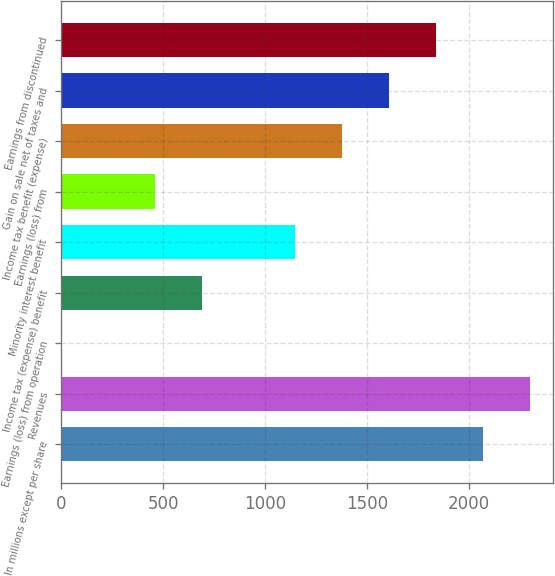<chart> <loc_0><loc_0><loc_500><loc_500><bar_chart><fcel>In millions except per share<fcel>Revenues<fcel>Earnings (loss) from operation<fcel>Income tax (expense) benefit<fcel>Minority interest benefit<fcel>Earnings (loss) from<fcel>Income tax benefit (expense)<fcel>Gain on sale net of taxes and<fcel>Earnings from discontinued<nl><fcel>2069.97<fcel>2300<fcel>0.06<fcel>690.03<fcel>1150.01<fcel>460.04<fcel>1380<fcel>1609.99<fcel>1839.98<nl></chart> 